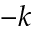<formula> <loc_0><loc_0><loc_500><loc_500>- k</formula> 